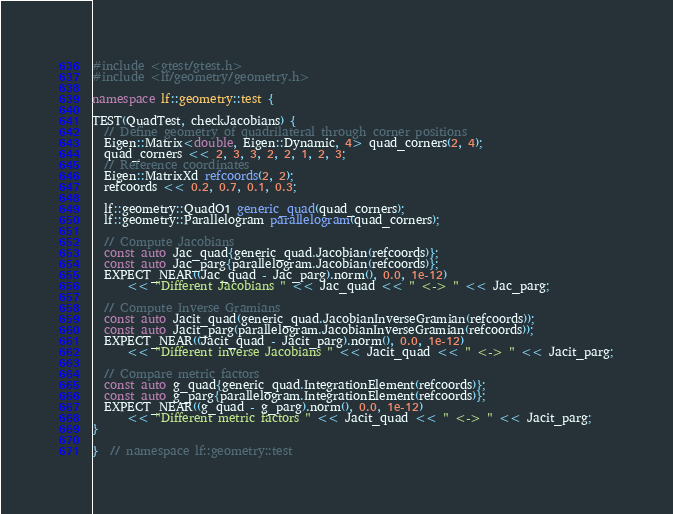<code> <loc_0><loc_0><loc_500><loc_500><_C++_>#include <gtest/gtest.h>
#include <lf/geometry/geometry.h>

namespace lf::geometry::test {

TEST(QuadTest, checkJacobians) {
  // Define geometry of quadrilateral through corner positions
  Eigen::Matrix<double, Eigen::Dynamic, 4> quad_corners(2, 4);
  quad_corners << 2, 3, 3, 2, 2, 1, 2, 3;
  // Reference coordinates
  Eigen::MatrixXd refcoords(2, 2);
  refcoords << 0.2, 0.7, 0.1, 0.3;

  lf::geometry::QuadO1 generic_quad(quad_corners);
  lf::geometry::Parallelogram parallelogram(quad_corners);

  // Compute Jacobians
  const auto Jac_quad{generic_quad.Jacobian(refcoords)};
  const auto Jac_parg{parallelogram.Jacobian(refcoords)};
  EXPECT_NEAR((Jac_quad - Jac_parg).norm(), 0.0, 1e-12)
      << "Different Jacobians " << Jac_quad << " <-> " << Jac_parg;

  // Compute Inverse Gramians
  const auto Jacit_quad(generic_quad.JacobianInverseGramian(refcoords));
  const auto Jacit_parg(parallelogram.JacobianInverseGramian(refcoords));
  EXPECT_NEAR((Jacit_quad - Jacit_parg).norm(), 0.0, 1e-12)
      << "Different inverse Jacobians " << Jacit_quad << " <-> " << Jacit_parg;

  // Compare metric factors
  const auto g_quad{generic_quad.IntegrationElement(refcoords)};
  const auto g_parg{parallelogram.IntegrationElement(refcoords)};
  EXPECT_NEAR((g_quad - g_parg).norm(), 0.0, 1e-12)
      << "Different metric factors " << Jacit_quad << " <-> " << Jacit_parg;
}

}  // namespace lf::geometry::test
</code> 